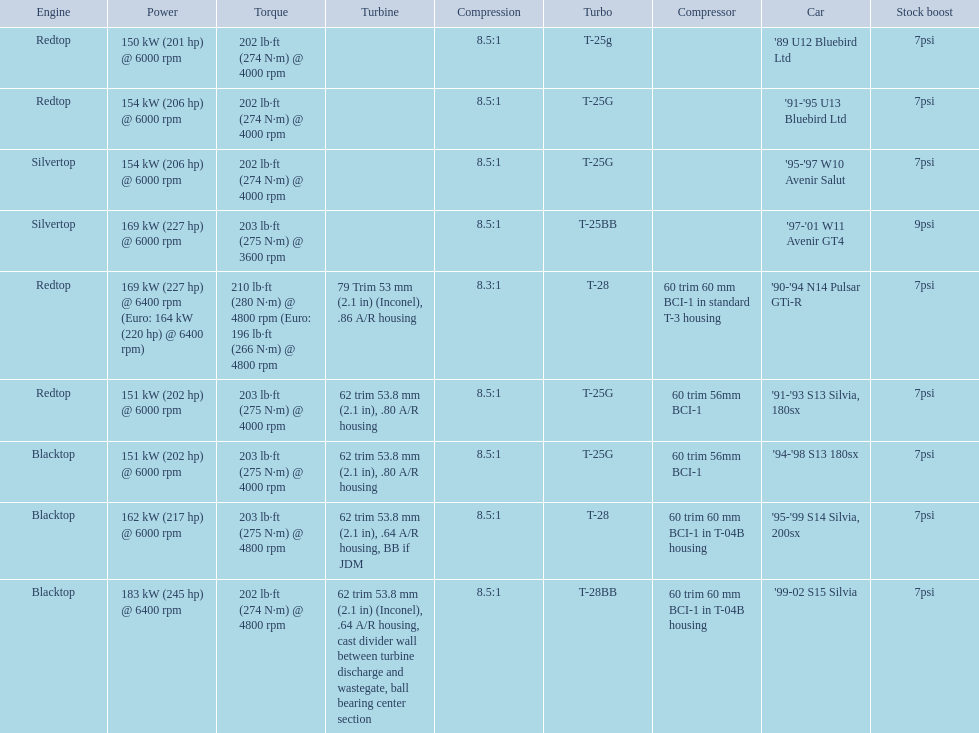Which engines were used after 1999? Silvertop, Blacktop. 